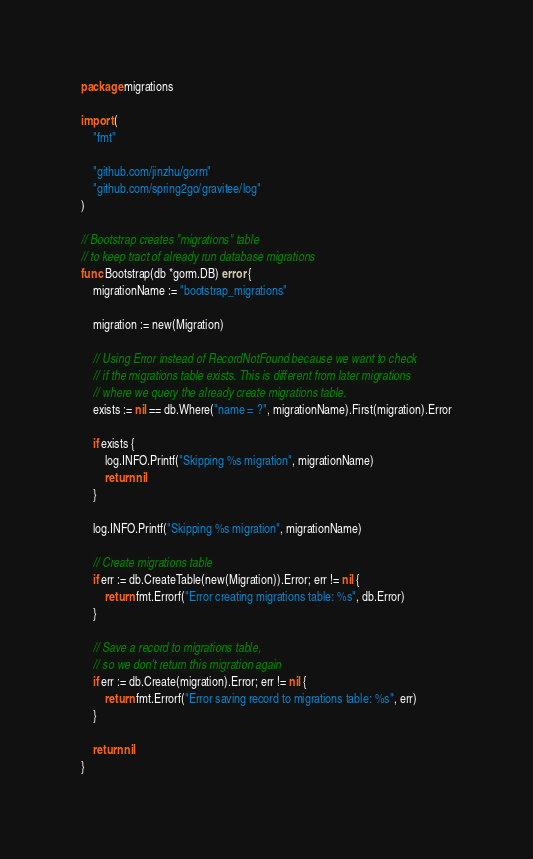Convert code to text. <code><loc_0><loc_0><loc_500><loc_500><_Go_>package migrations

import (
	"fmt"

	"github.com/jinzhu/gorm"
	"github.com/spring2go/gravitee/log"
)

// Bootstrap creates "migrations" table
// to keep tract of already run database migrations
func Bootstrap(db *gorm.DB) error {
	migrationName := "bootstrap_migrations"

	migration := new(Migration)

	// Using Error instead of RecordNotFound because we want to check
	// if the migrations table exists. This is different from later migrations
	// where we query the already create migrations table.
	exists := nil == db.Where("name = ?", migrationName).First(migration).Error

	if exists {
		log.INFO.Printf("Skipping %s migration", migrationName)
		return nil
	}

	log.INFO.Printf("Skipping %s migration", migrationName)

	// Create migrations table
	if err := db.CreateTable(new(Migration)).Error; err != nil {
		return fmt.Errorf("Error creating migrations table: %s", db.Error)
	}

	// Save a record to migrations table,
	// so we don't return this migration again
	if err := db.Create(migration).Error; err != nil {
		return fmt.Errorf("Error saving record to migrations table: %s", err)
	}

	return nil
}
</code> 